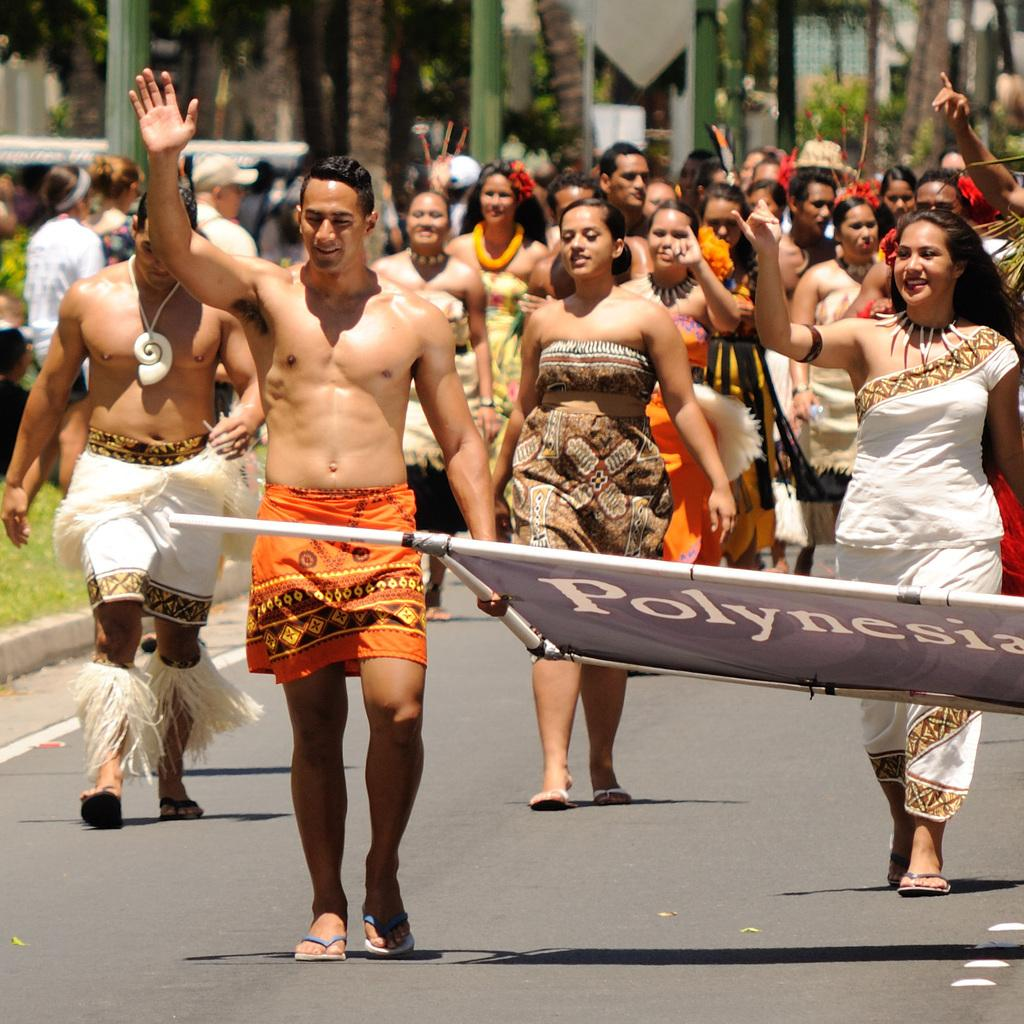What are the people in the image doing? The people in the image are walking on the road. What else can be seen in the image besides the people walking? There is a banner visible in the image, and grass is present as well. Can you describe the background of the image? The background of the image is blurry, but there are people and trees visible in the background. How many bikes are being ridden by the people in the image? There are no bikes present in the image; the people are walking on the road. What type of request can be seen on the banner in the image? There is no request visible on the banner in the image; it is not mentioned in the provided facts. 